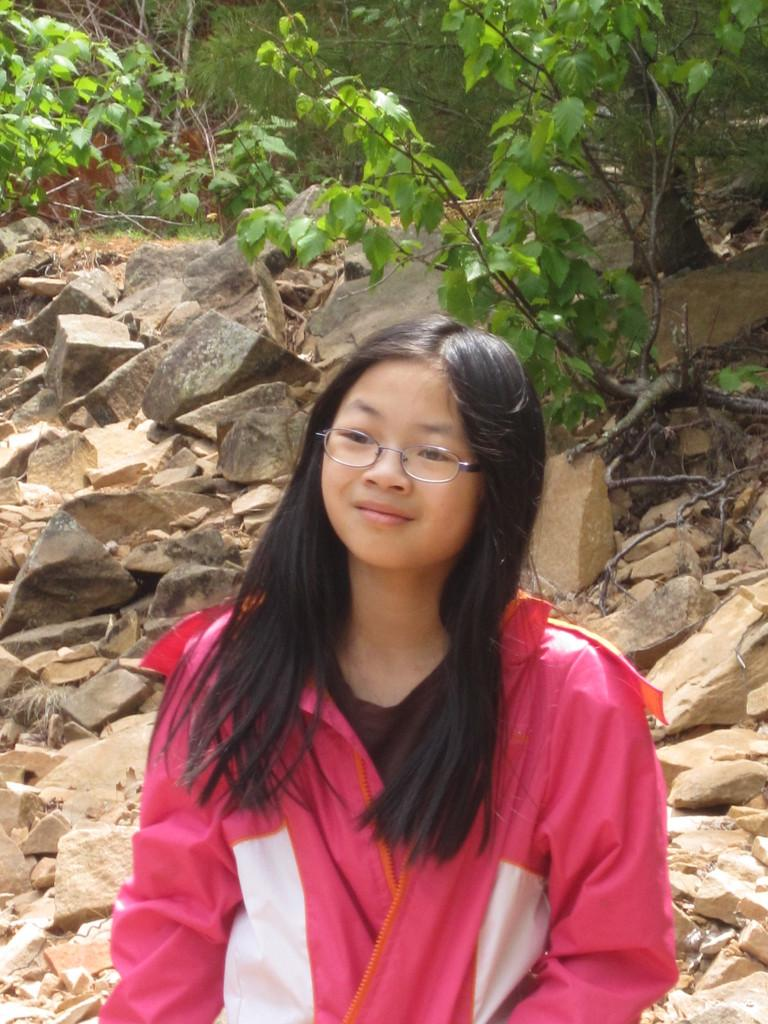Who is the main subject in the picture? There is a girl in the picture. What is the girl doing in the image? The girl is standing. What is the girl wearing in the image? The girl is wearing a pink jacket. What can be seen in the background of the image? There are rocks and plants visible in the background of the image. What type of fiction is the girl reading in the image? There is no book or any indication of reading in the image, so it cannot be determined if the girl is reading fiction or any other type of material. 